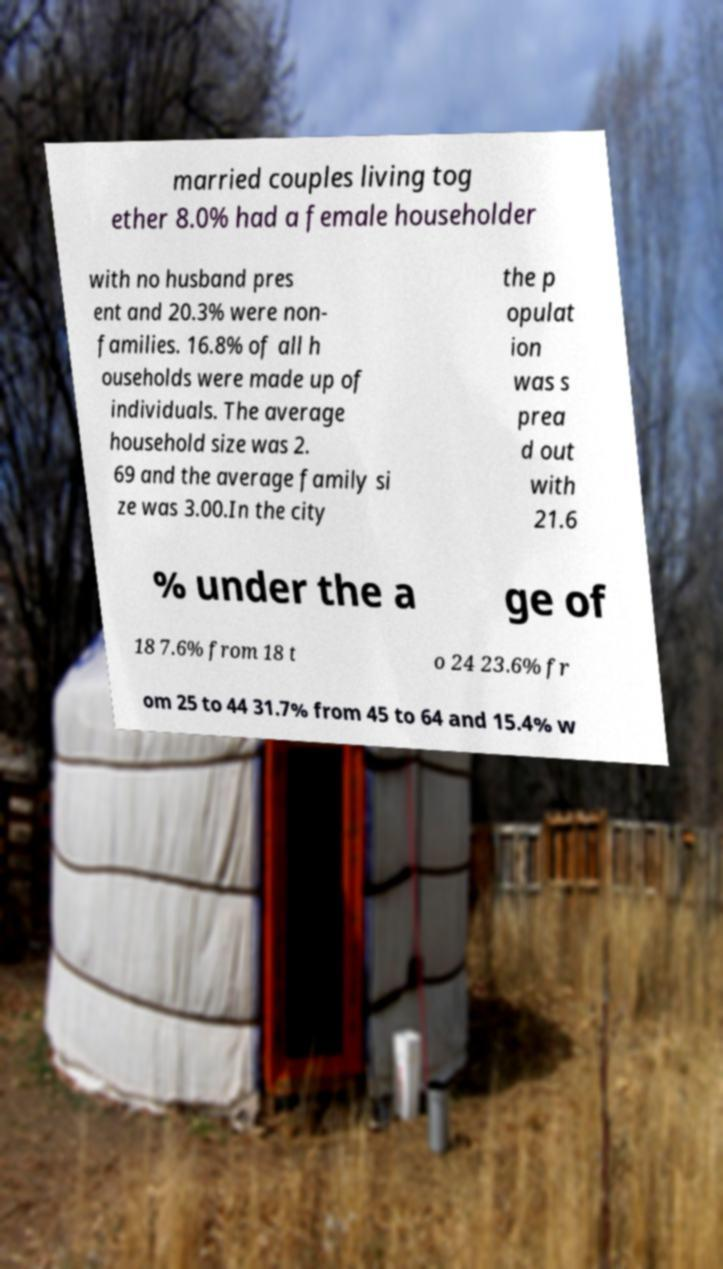I need the written content from this picture converted into text. Can you do that? married couples living tog ether 8.0% had a female householder with no husband pres ent and 20.3% were non- families. 16.8% of all h ouseholds were made up of individuals. The average household size was 2. 69 and the average family si ze was 3.00.In the city the p opulat ion was s prea d out with 21.6 % under the a ge of 18 7.6% from 18 t o 24 23.6% fr om 25 to 44 31.7% from 45 to 64 and 15.4% w 